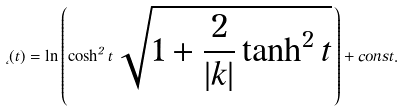<formula> <loc_0><loc_0><loc_500><loc_500>\Phi ( t ) = \ln \left ( \cosh ^ { 2 } t \, \sqrt { 1 + \frac { 2 } { | k | } \tanh ^ { 2 } t } \, \right ) + c o n s t .</formula> 